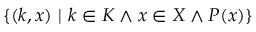Convert formula to latex. <formula><loc_0><loc_0><loc_500><loc_500>\{ ( k , x ) \ | \ k \in K \wedge x \in X \wedge P ( x ) \}</formula> 